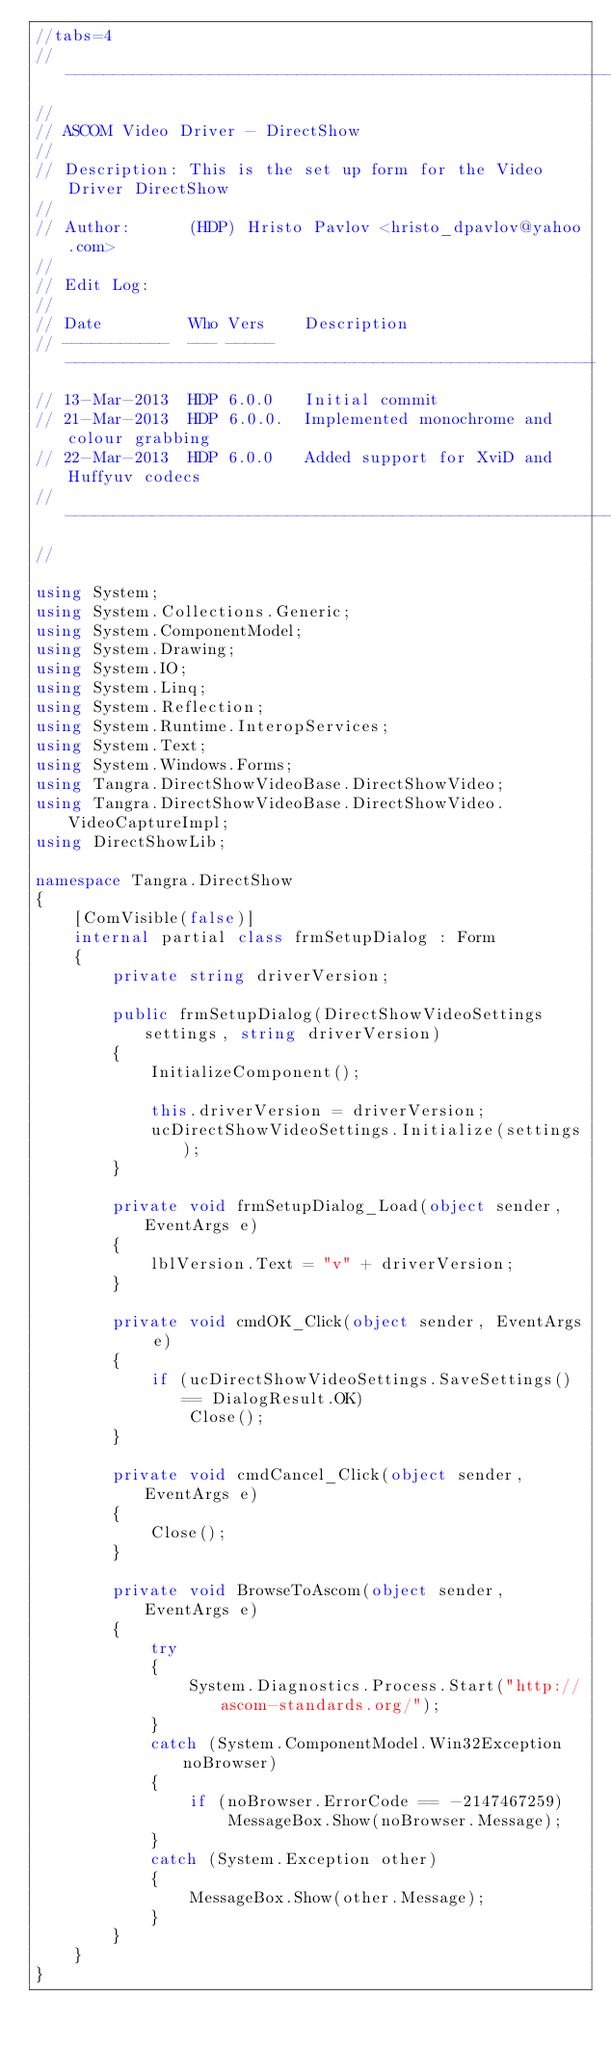Convert code to text. <code><loc_0><loc_0><loc_500><loc_500><_C#_>//tabs=4
// --------------------------------------------------------------------------------
//
// ASCOM Video Driver - DirectShow
//
// Description:	This is the set up form for the Video Driver DirectShow 
//
// Author:		(HDP) Hristo Pavlov <hristo_dpavlov@yahoo.com>
//
// Edit Log:
//
// Date			Who	Vers	Description
// -----------	---	-----	-------------------------------------------------------
// 13-Mar-2013	HDP	6.0.0	Initial commit
// 21-Mar-2013	HDP	6.0.0.	Implemented monochrome and colour grabbing
// 22-Mar-2013	HDP	6.0.0	Added support for XviD and Huffyuv codecs
// --------------------------------------------------------------------------------
//

using System;
using System.Collections.Generic;
using System.ComponentModel;
using System.Drawing;
using System.IO;
using System.Linq;
using System.Reflection;
using System.Runtime.InteropServices;
using System.Text;
using System.Windows.Forms;
using Tangra.DirectShowVideoBase.DirectShowVideo;
using Tangra.DirectShowVideoBase.DirectShowVideo.VideoCaptureImpl;
using DirectShowLib;

namespace Tangra.DirectShow
{
	[ComVisible(false)]
	internal partial class frmSetupDialog : Form
	{
		private string driverVersion;

		public frmSetupDialog(DirectShowVideoSettings settings, string driverVersion)
		{
			InitializeComponent();

			this.driverVersion = driverVersion;
			ucDirectShowVideoSettings.Initialize(settings);
		}

		private void frmSetupDialog_Load(object sender, EventArgs e)
		{
			lblVersion.Text = "v" + driverVersion;
		}

		private void cmdOK_Click(object sender, EventArgs e)
		{
			if (ucDirectShowVideoSettings.SaveSettings() == DialogResult.OK)
				Close();
		}

		private void cmdCancel_Click(object sender, EventArgs e)
		{
			Close();
		}

		private void BrowseToAscom(object sender, EventArgs e)
		{
			try
			{
				System.Diagnostics.Process.Start("http://ascom-standards.org/");
			}
			catch (System.ComponentModel.Win32Exception noBrowser)
			{
				if (noBrowser.ErrorCode == -2147467259)
					MessageBox.Show(noBrowser.Message);
			}
			catch (System.Exception other)
			{
				MessageBox.Show(other.Message);
			}
		}
	}
}</code> 